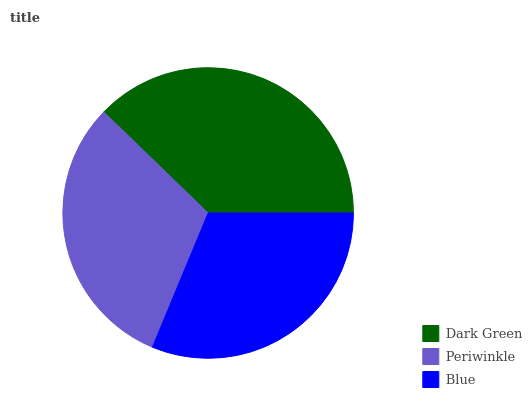Is Periwinkle the minimum?
Answer yes or no. Yes. Is Dark Green the maximum?
Answer yes or no. Yes. Is Blue the minimum?
Answer yes or no. No. Is Blue the maximum?
Answer yes or no. No. Is Blue greater than Periwinkle?
Answer yes or no. Yes. Is Periwinkle less than Blue?
Answer yes or no. Yes. Is Periwinkle greater than Blue?
Answer yes or no. No. Is Blue less than Periwinkle?
Answer yes or no. No. Is Blue the high median?
Answer yes or no. Yes. Is Blue the low median?
Answer yes or no. Yes. Is Periwinkle the high median?
Answer yes or no. No. Is Periwinkle the low median?
Answer yes or no. No. 